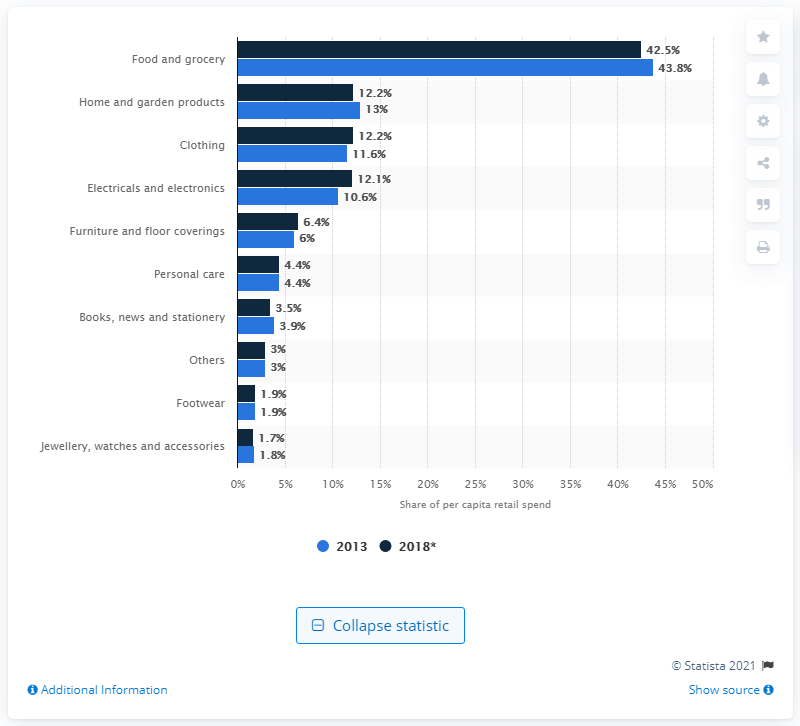Give some essential details in this illustration. In 2013, food and grocery products accounted for the largest portion of retail spending in Germany. In 2013, the largest portion of retail spending in Germany was 43.8%. 